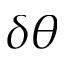Convert formula to latex. <formula><loc_0><loc_0><loc_500><loc_500>\delta \theta</formula> 